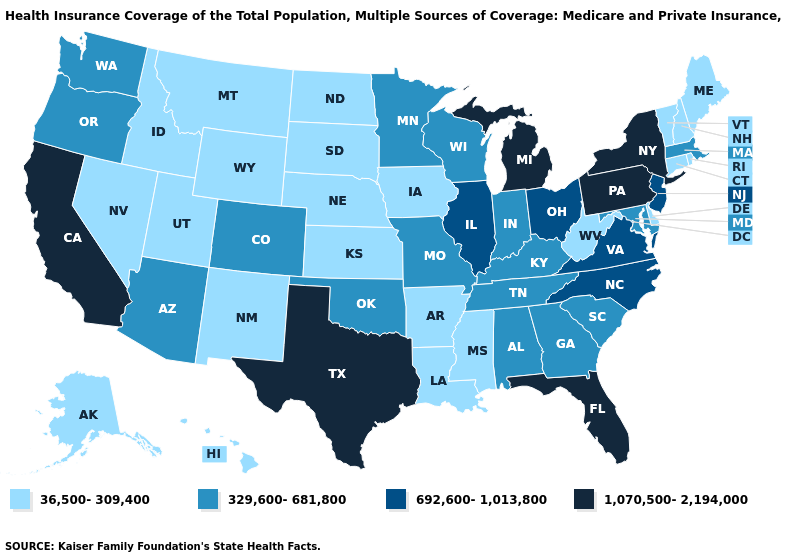What is the highest value in the Northeast ?
Write a very short answer. 1,070,500-2,194,000. What is the highest value in states that border Nevada?
Concise answer only. 1,070,500-2,194,000. What is the value of Mississippi?
Short answer required. 36,500-309,400. Does Arkansas have the lowest value in the South?
Short answer required. Yes. Name the states that have a value in the range 692,600-1,013,800?
Answer briefly. Illinois, New Jersey, North Carolina, Ohio, Virginia. What is the value of Indiana?
Answer briefly. 329,600-681,800. Among the states that border Colorado , does Arizona have the highest value?
Write a very short answer. Yes. Does Georgia have the lowest value in the USA?
Write a very short answer. No. Does Florida have the highest value in the USA?
Concise answer only. Yes. What is the highest value in the South ?
Short answer required. 1,070,500-2,194,000. Name the states that have a value in the range 36,500-309,400?
Be succinct. Alaska, Arkansas, Connecticut, Delaware, Hawaii, Idaho, Iowa, Kansas, Louisiana, Maine, Mississippi, Montana, Nebraska, Nevada, New Hampshire, New Mexico, North Dakota, Rhode Island, South Dakota, Utah, Vermont, West Virginia, Wyoming. Name the states that have a value in the range 36,500-309,400?
Keep it brief. Alaska, Arkansas, Connecticut, Delaware, Hawaii, Idaho, Iowa, Kansas, Louisiana, Maine, Mississippi, Montana, Nebraska, Nevada, New Hampshire, New Mexico, North Dakota, Rhode Island, South Dakota, Utah, Vermont, West Virginia, Wyoming. Name the states that have a value in the range 329,600-681,800?
Give a very brief answer. Alabama, Arizona, Colorado, Georgia, Indiana, Kentucky, Maryland, Massachusetts, Minnesota, Missouri, Oklahoma, Oregon, South Carolina, Tennessee, Washington, Wisconsin. Name the states that have a value in the range 692,600-1,013,800?
Answer briefly. Illinois, New Jersey, North Carolina, Ohio, Virginia. Which states have the highest value in the USA?
Write a very short answer. California, Florida, Michigan, New York, Pennsylvania, Texas. 